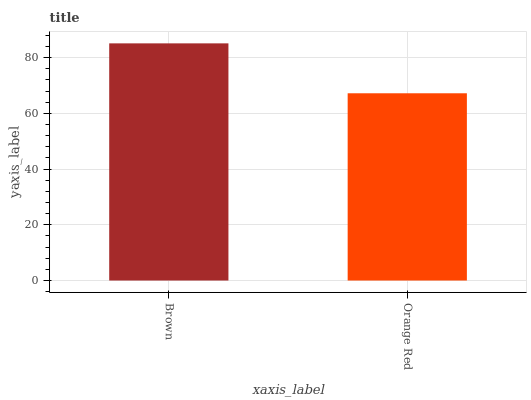Is Orange Red the minimum?
Answer yes or no. Yes. Is Brown the maximum?
Answer yes or no. Yes. Is Orange Red the maximum?
Answer yes or no. No. Is Brown greater than Orange Red?
Answer yes or no. Yes. Is Orange Red less than Brown?
Answer yes or no. Yes. Is Orange Red greater than Brown?
Answer yes or no. No. Is Brown less than Orange Red?
Answer yes or no. No. Is Brown the high median?
Answer yes or no. Yes. Is Orange Red the low median?
Answer yes or no. Yes. Is Orange Red the high median?
Answer yes or no. No. Is Brown the low median?
Answer yes or no. No. 